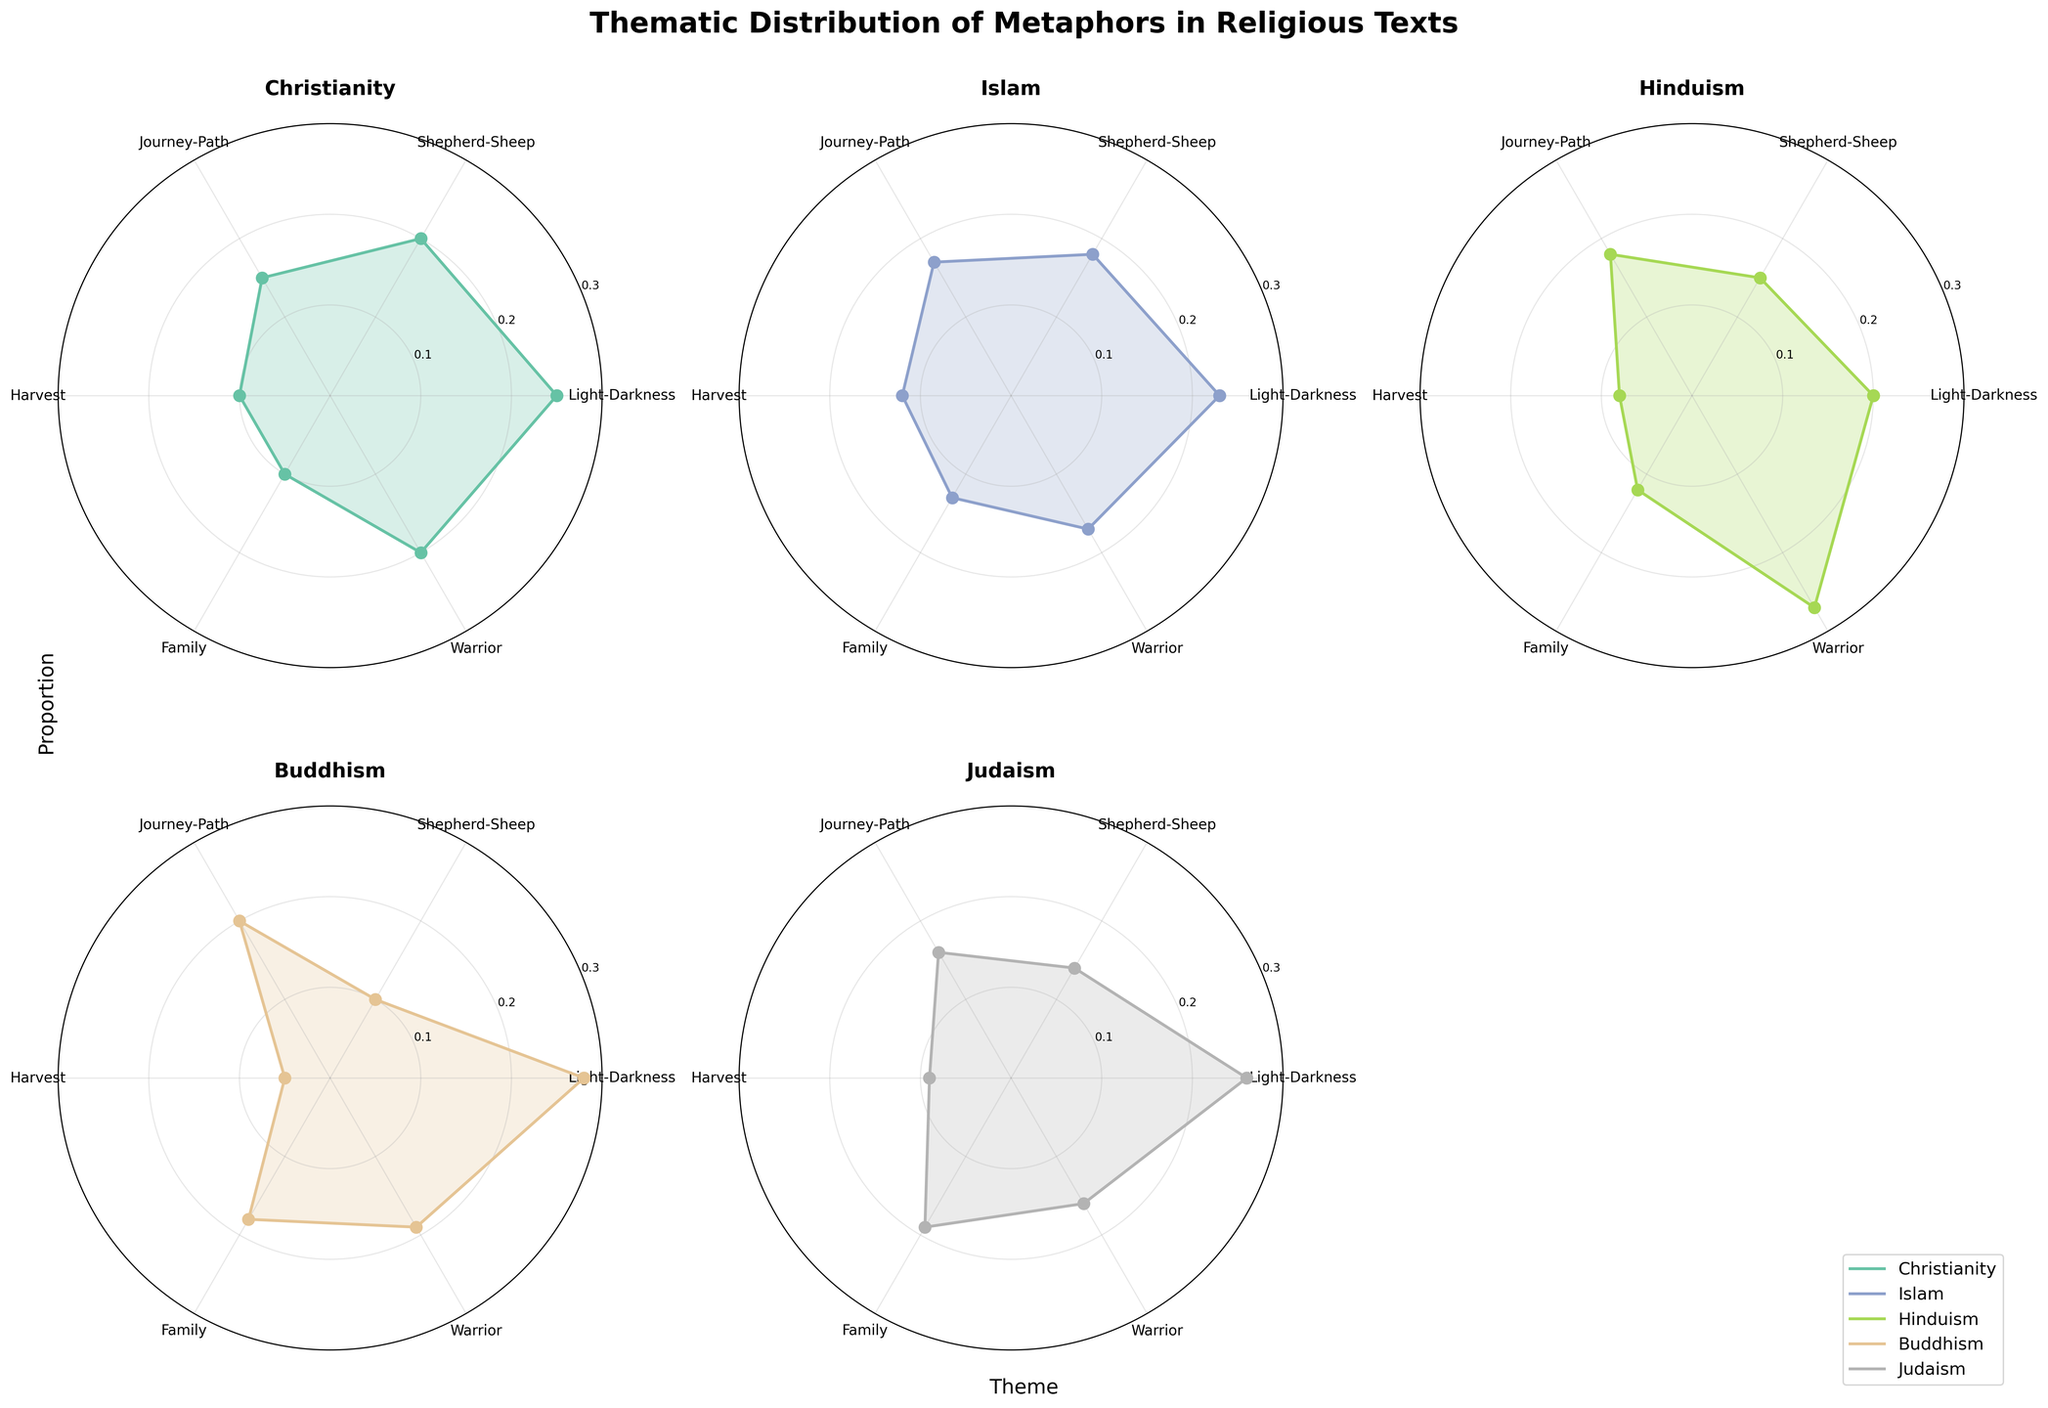What's the most prominent theme in Buddhism? By examining the plot for Buddhism, the line and filled area representing "Light-Darkness" extend the furthest from the center of the polar chart, indicating the highest proportion among the themes for Buddhism.
Answer: Light-Darkness Which faith tradition has the highest proportion for the "Warrior" theme? Comparing the plots for all faith traditions, the line representing the "Warrior" theme is furthest from the center for Hinduism, showing the highest proportion for this theme.
Answer: Hinduism How does the proportion of the "Journey-Path" theme in Islam compare to Christianity? In Islam, the "Journey-Path" theme has a proportion represented by a point closer to the center compared to Christianity. By visual inspection, Islam's proportion is slightly higher, marked around 0.17, while Christianity's proportion is around 0.15.
Answer: Islam has a slightly higher proportion What is the average proportion of the "Family" theme across all faith traditions? Summing the proportions of the "Family" theme for all faiths and dividing by the number of faiths (5): (0.10 (Christianity) + 0.13 (Islam) + 0.12 (Hinduism) + 0.18 (Buddhism) + 0.19 (Judaism)) / 5 = 0.144.
Answer: 0.144 What's the least represented theme in Buddhism? The plot for Buddhism shows the shortest line extending from the center for the "Harvest" theme, indicating the lowest proportion among the themes for Buddhism.
Answer: Harvest Which faith tradition has the closest proportions for "Shepherd-Sheep" and "Warrior" themes? By comparing the plots for all faith traditions, Buddhism has proportion lines for "Shepherd-Sheep" and "Warrior" that are closest to each other (around 0.10 and 0.19, respectively).
Answer: Buddhism Is the "Light-Darkness" theme more prominent in Judaism or Christianity? By comparing the polar plots for both faiths, the line for "Light-Darkness" extends further for Judaism (around 0.26) than for Christianity (around 0.25).
Answer: Judaism What proportion difference exists between the highest and lowest themes in Hinduism? The highest theme proportion in Hinduism is "Warrior" (0.27), and the lowest is "Harvest" (0.08). The difference is 0.27 - 0.08 = 0.19.
Answer: 0.19 Are there any themes with identical proportions across two or more faith traditions? By inspecting the individual plots for all faith traditions, no themes have exactly identical proportions across any two or more faiths.
Answer: No How does the average proportion for the "Harvest" theme across all faith traditions compare to its proportion in Christianity? The average proportion for the "Harvest" theme across all faiths is (0.10 (Christianity) + 0.12 (Islam) + 0.08 (Hinduism) + 0.05 (Buddhism) + 0.09 (Judaism)) / 5 = 0.088. This is slightly less than its proportion in Christianity 0.10.
Answer: Slightly less 